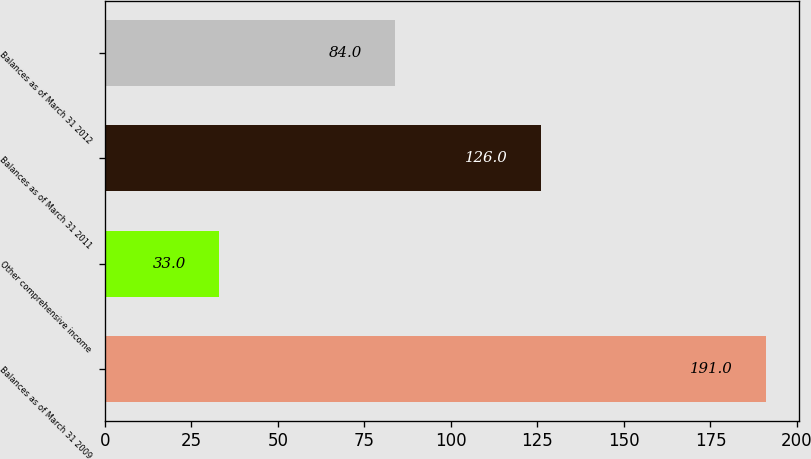<chart> <loc_0><loc_0><loc_500><loc_500><bar_chart><fcel>Balances as of March 31 2009<fcel>Other comprehensive income<fcel>Balances as of March 31 2011<fcel>Balances as of March 31 2012<nl><fcel>191<fcel>33<fcel>126<fcel>84<nl></chart> 